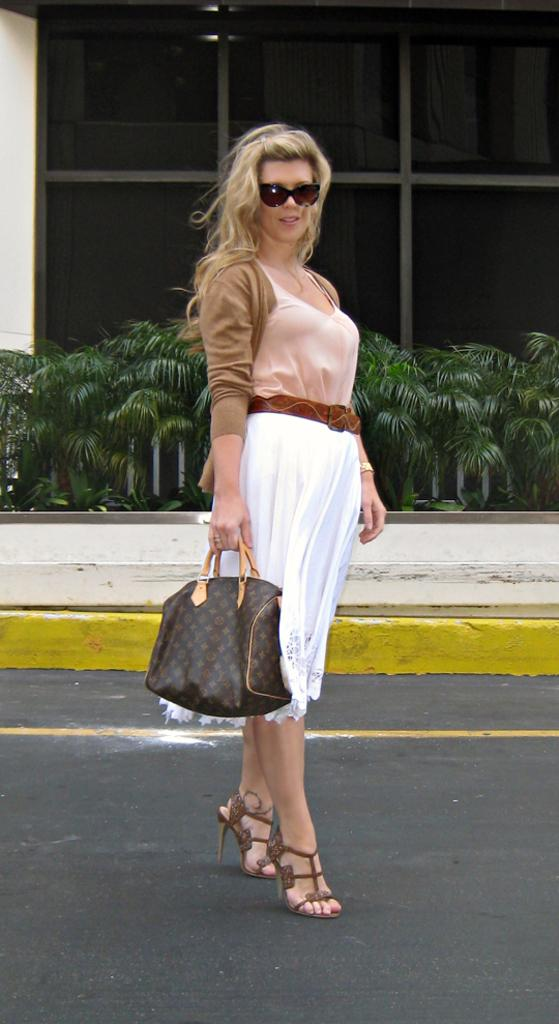Who is the main subject in the image? There is a woman in the image. What is the woman doing in the image? The woman is standing on the road. What is the woman holding in her hand? The woman is holding a bag in her hand. What accessory is the woman wearing? The woman is wearing spectacles. What can be seen in the background of the image? There are plants and a window visible in the background of the image. What type of ice can be seen melting on the woman's head in the image? There is no ice present in the image, and therefore no ice can be seen melting on the woman's head. 